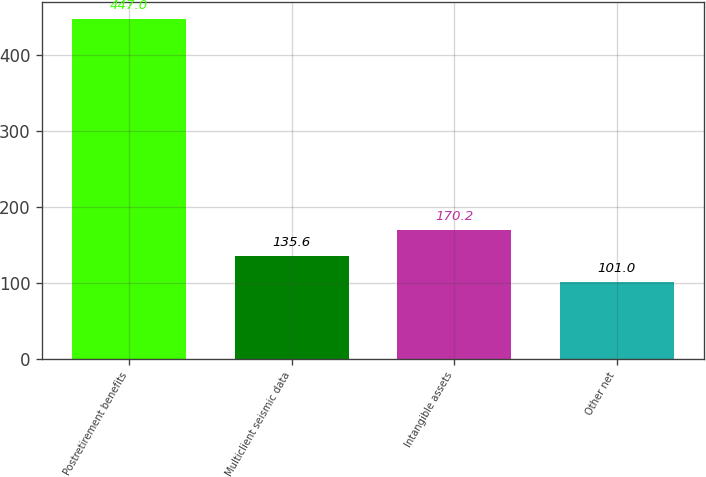<chart> <loc_0><loc_0><loc_500><loc_500><bar_chart><fcel>Postretirement benefits<fcel>Multiclient seismic data<fcel>Intangible assets<fcel>Other net<nl><fcel>447<fcel>135.6<fcel>170.2<fcel>101<nl></chart> 